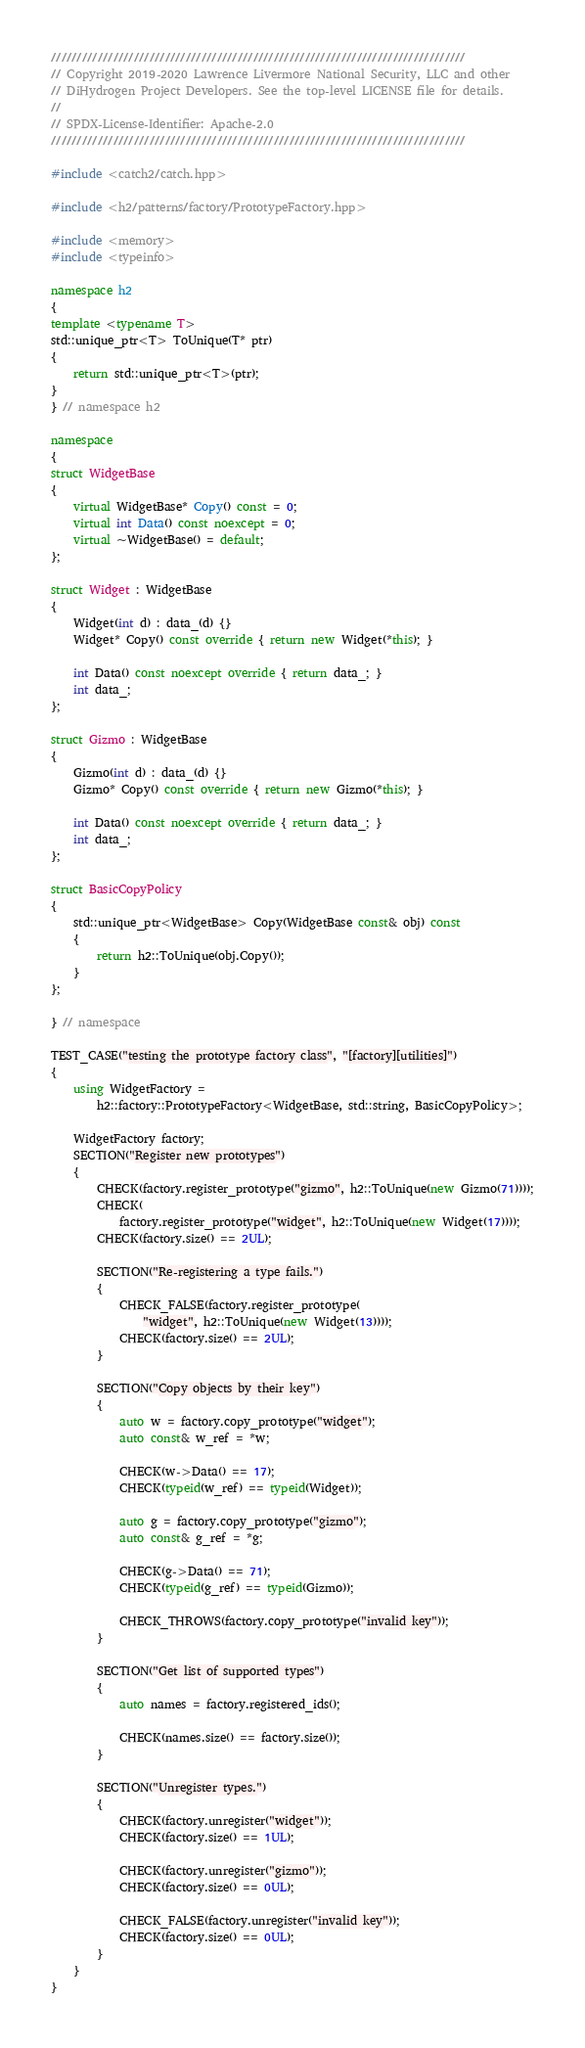<code> <loc_0><loc_0><loc_500><loc_500><_C++_>////////////////////////////////////////////////////////////////////////////////
// Copyright 2019-2020 Lawrence Livermore National Security, LLC and other
// DiHydrogen Project Developers. See the top-level LICENSE file for details.
//
// SPDX-License-Identifier: Apache-2.0
////////////////////////////////////////////////////////////////////////////////

#include <catch2/catch.hpp>

#include <h2/patterns/factory/PrototypeFactory.hpp>

#include <memory>
#include <typeinfo>

namespace h2
{
template <typename T>
std::unique_ptr<T> ToUnique(T* ptr)
{
    return std::unique_ptr<T>(ptr);
}
} // namespace h2

namespace
{
struct WidgetBase
{
    virtual WidgetBase* Copy() const = 0;
    virtual int Data() const noexcept = 0;
    virtual ~WidgetBase() = default;
};

struct Widget : WidgetBase
{
    Widget(int d) : data_(d) {}
    Widget* Copy() const override { return new Widget(*this); }

    int Data() const noexcept override { return data_; }
    int data_;
};

struct Gizmo : WidgetBase
{
    Gizmo(int d) : data_(d) {}
    Gizmo* Copy() const override { return new Gizmo(*this); }

    int Data() const noexcept override { return data_; }
    int data_;
};

struct BasicCopyPolicy
{
    std::unique_ptr<WidgetBase> Copy(WidgetBase const& obj) const
    {
        return h2::ToUnique(obj.Copy());
    }
};

} // namespace

TEST_CASE("testing the prototype factory class", "[factory][utilities]")
{
    using WidgetFactory =
        h2::factory::PrototypeFactory<WidgetBase, std::string, BasicCopyPolicy>;

    WidgetFactory factory;
    SECTION("Register new prototypes")
    {
        CHECK(factory.register_prototype("gizmo", h2::ToUnique(new Gizmo(71))));
        CHECK(
            factory.register_prototype("widget", h2::ToUnique(new Widget(17))));
        CHECK(factory.size() == 2UL);

        SECTION("Re-registering a type fails.")
        {
            CHECK_FALSE(factory.register_prototype(
                "widget", h2::ToUnique(new Widget(13))));
            CHECK(factory.size() == 2UL);
        }

        SECTION("Copy objects by their key")
        {
            auto w = factory.copy_prototype("widget");
            auto const& w_ref = *w;

            CHECK(w->Data() == 17);
            CHECK(typeid(w_ref) == typeid(Widget));

            auto g = factory.copy_prototype("gizmo");
            auto const& g_ref = *g;

            CHECK(g->Data() == 71);
            CHECK(typeid(g_ref) == typeid(Gizmo));

            CHECK_THROWS(factory.copy_prototype("invalid key"));
        }

        SECTION("Get list of supported types")
        {
            auto names = factory.registered_ids();

            CHECK(names.size() == factory.size());
        }

        SECTION("Unregister types.")
        {
            CHECK(factory.unregister("widget"));
            CHECK(factory.size() == 1UL);

            CHECK(factory.unregister("gizmo"));
            CHECK(factory.size() == 0UL);

            CHECK_FALSE(factory.unregister("invalid key"));
            CHECK(factory.size() == 0UL);
        }
    }
}
</code> 